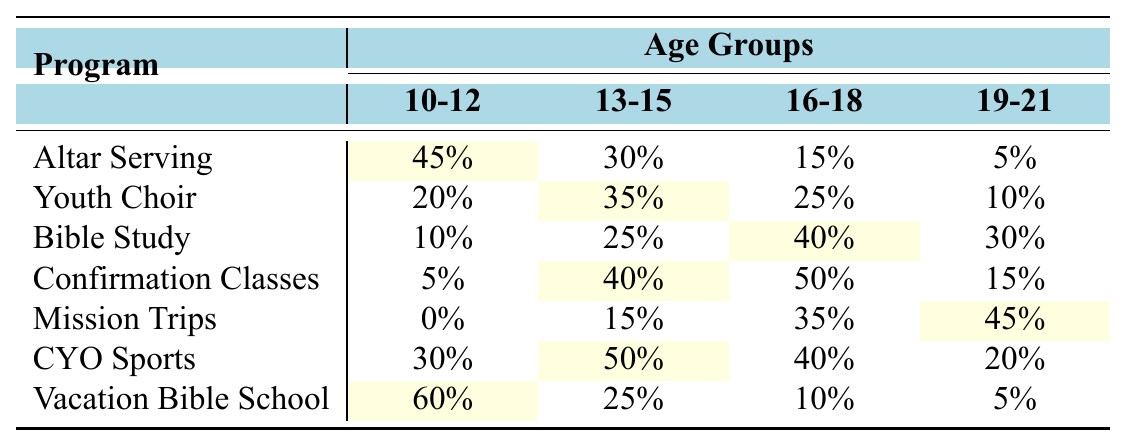What age group has the highest participation rate in Altar Serving? Looking at the Altar Serving row, the highest participation rate is 45% in the age group 10-12.
Answer: 10-12 Which program has the lowest participation rate among the 19-21 age group? In the 19-21 age group, the participation rates for the different programs are 5%, 10%, 30%, 15%, 45%, 20%, and 5%. The lowest is 5% in both Altar Serving and Vacation Bible School.
Answer: 5% What is the participation rate difference between the 10-12 and 16-18 age groups for Confirmation Classes? The participation rate for Confirmation Classes is 5% for 10-12 and 50% for 16-18. The difference is 50% - 5% = 45%.
Answer: 45% Is the participation rate in Youth Choir for the 16-18 age group higher than that for the 19-21 age group? The participation rate for the 16-18 age group in Youth Choir is 25%, while for the 19-21 age group, it is 10%. Since 25% is greater than 10%, the statement is true.
Answer: Yes What program has the highest overall participation rate across all age groups? To find the overall highest rate, we can look at each program's highest rate: Altar Serving has 45%, Youth Choir has 35%, Bible Study has 40%, Confirmation Classes has 50%, Mission Trips has 45%, CYO Sports has 50%, and Vacation Bible School has 60%. The highest is 60% for Vacation Bible School.
Answer: Vacation Bible School What is the average participation rate for the 13-15 age group across all programs? The participation rates for the 13-15 age group are: 30%, 35%, 25%, 40%, 15%, 50%, and 25%. The sum is (30 + 35 + 25 + 40 + 15 + 50 + 25) = 220%. With 7 data points, the average is 220% / 7 = 31.43%.
Answer: 31.43% Which age group shows the most potential for Mission Trips based on participation rates? In the age group 19-21, the participation rate for Mission Trips is 45%, which is the highest among the age groups. This suggests strong potential interest in the program from this age group.
Answer: 19-21 Calculate the combined participation rate for Vacation Bible School in the 10-12 and 13-15 age groups. The participation rates for Vacation Bible School are 60% for 10-12 and 25% for 13-15. The combined rate is 60% + 25% = 85%.
Answer: 85% Among all programs, which has the most consistent participation rates across age groups? Looking at each program, Altar Serving has rates of 45%, 30%, 15%, and 5%; Youth Choir has 20%, 35%, 25%, and 10%; Bible Study has 10%, 25%, 40%, and 30%; Confirmation Classes has 5%, 40%, 50%, and 15%; Mission Trips has 0%, 15%, 35%, and 45%; CYO Sports has 30%, 50%, 40%, and 20%; and Vacation Bible School has 60%, 25%, 10%, and 5%. CYO Sports shows a pattern that is relatively closer (20%-50%) compared to others.
Answer: CYO Sports What percentage of youth aged 16-18 participate in Confirmation Classes? Referring to the Confirmation Classes row for the 16-18 age group, the participation rate is 50%.
Answer: 50% 